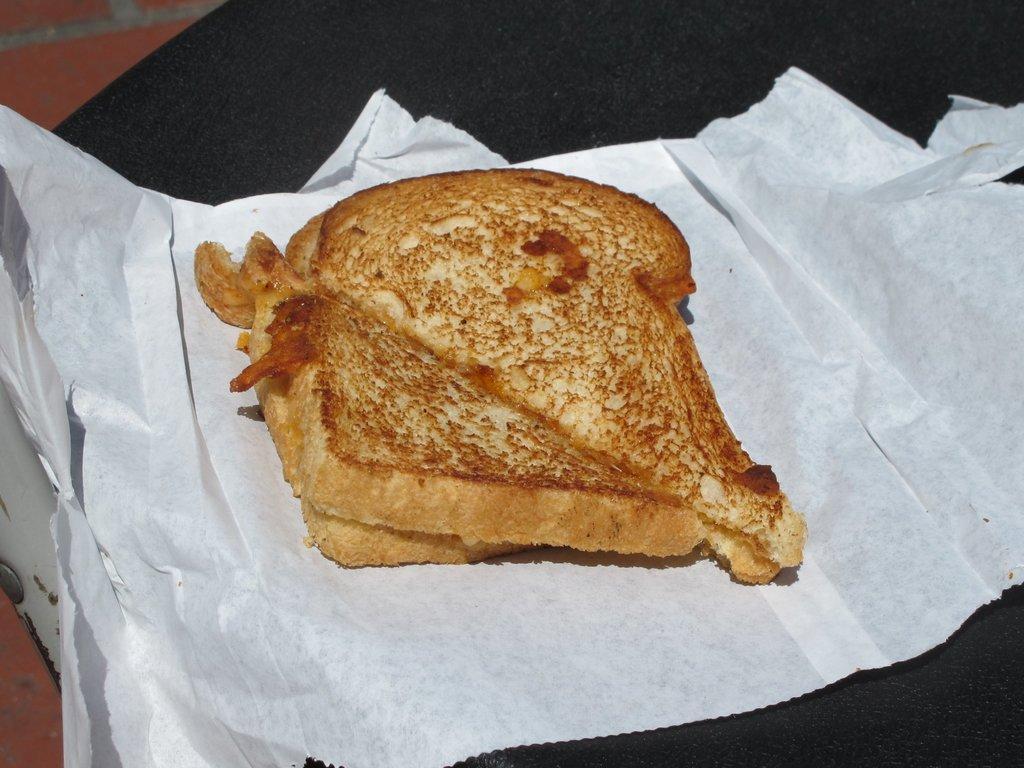Describe this image in one or two sentences. In this image I can see a food on the white paper. Food is in brown color. It is on the black surface. 